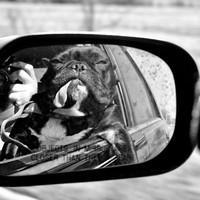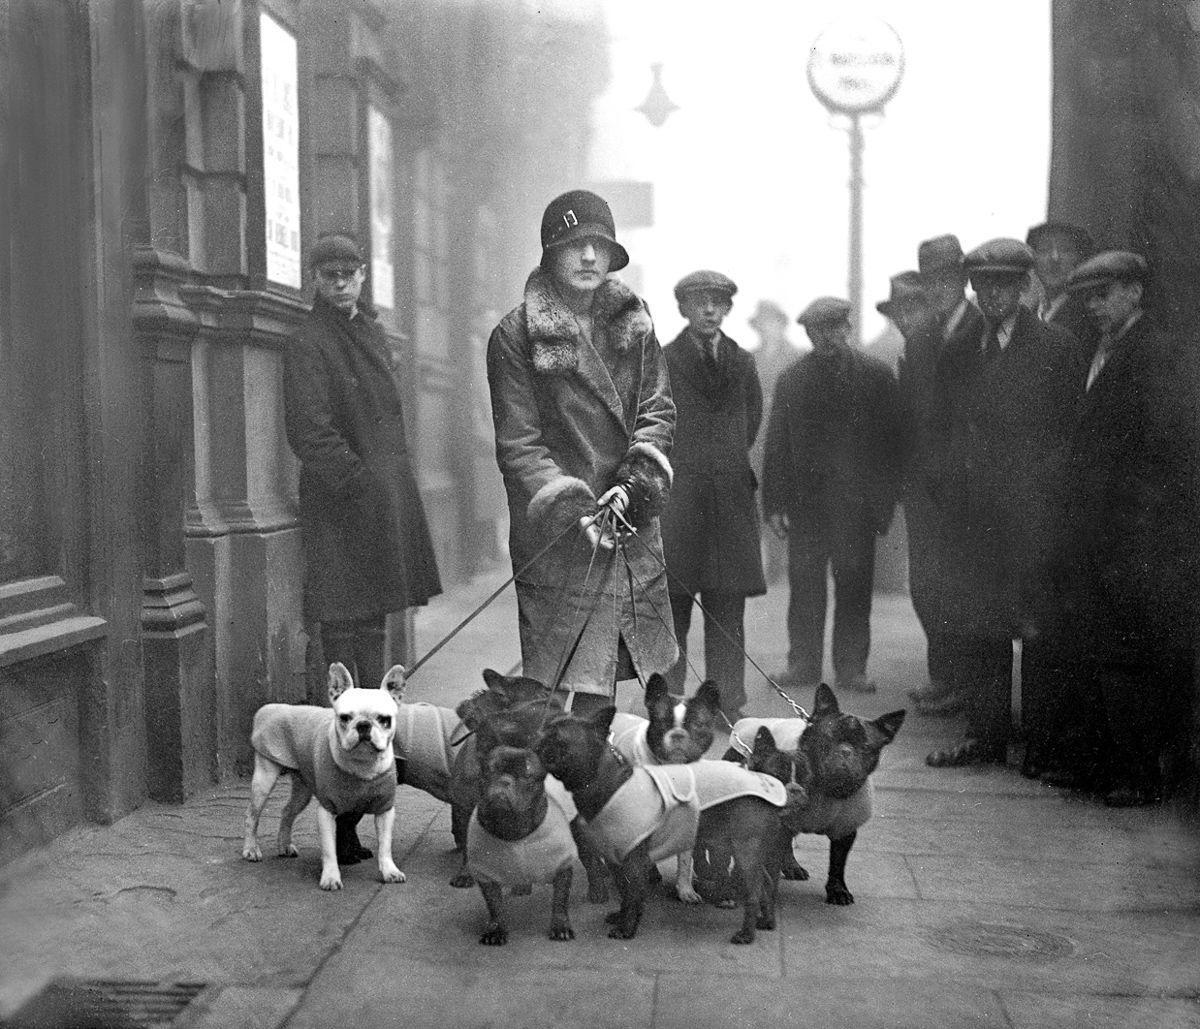The first image is the image on the left, the second image is the image on the right. Considering the images on both sides, is "In one of the images the dog is wearing a hat." valid? Answer yes or no. No. 